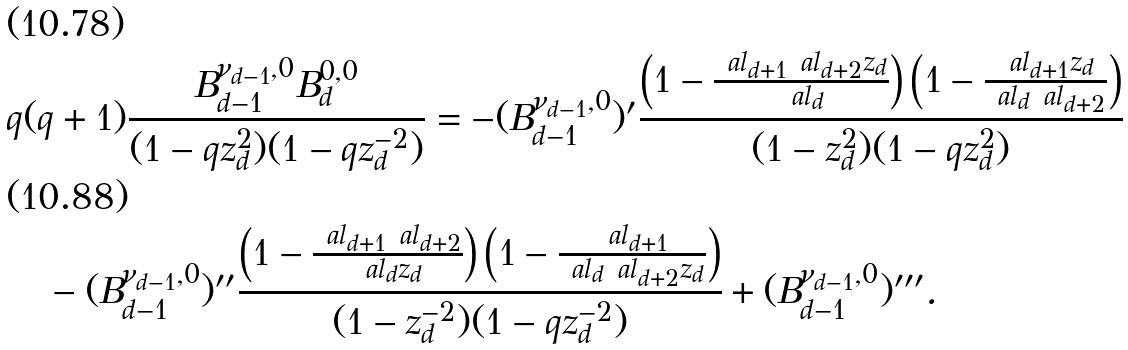Convert formula to latex. <formula><loc_0><loc_0><loc_500><loc_500>& q ( q + 1 ) \frac { B _ { d - 1 } ^ { \nu _ { d - 1 } , 0 } B _ { d } ^ { 0 , 0 } } { ( 1 - q z _ { d } ^ { 2 } ) ( 1 - q z _ { d } ^ { - 2 } ) } = - ( B _ { d - 1 } ^ { \nu _ { d - 1 } , 0 } ) ^ { \prime } \frac { \left ( 1 - \frac { \ a l _ { d + 1 } \ a l _ { d + 2 } z _ { d } } { \ a l _ { d } } \right ) \left ( 1 - \frac { \ a l _ { d + 1 } z _ { d } } { \ a l _ { d } \ a l _ { d + 2 } } \right ) } { ( 1 - z _ { d } ^ { 2 } ) ( 1 - q z _ { d } ^ { 2 } ) } \\ & \quad - ( B _ { d - 1 } ^ { \nu _ { d - 1 } , 0 } ) ^ { \prime \prime } \frac { \left ( 1 - \frac { \ a l _ { d + 1 } \ a l _ { d + 2 } } { \ a l _ { d } z _ { d } } \right ) \left ( 1 - \frac { \ a l _ { d + 1 } } { \ a l _ { d } \ a l _ { d + 2 } z _ { d } } \right ) } { ( 1 - z _ { d } ^ { - 2 } ) ( 1 - q z _ { d } ^ { - 2 } ) } + ( B _ { d - 1 } ^ { \nu _ { d - 1 } , 0 } ) ^ { \prime \prime \prime } .</formula> 